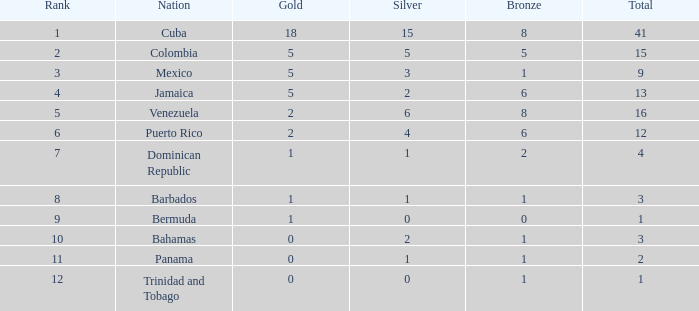Which Total is the lowest one that has a Rank smaller than 2, and a Silver smaller than 15? None. 